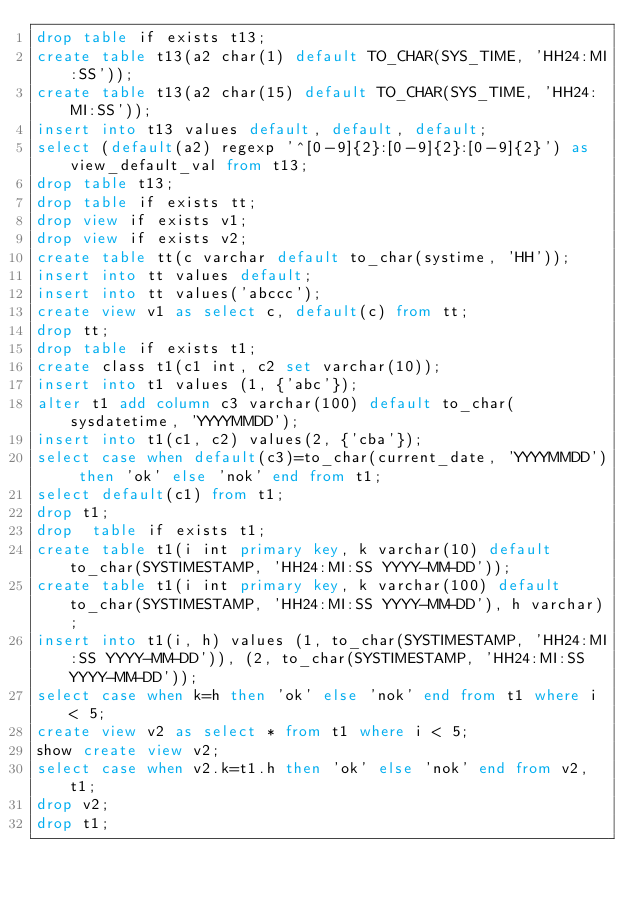<code> <loc_0><loc_0><loc_500><loc_500><_SQL_>drop table if exists t13;
create table t13(a2 char(1) default TO_CHAR(SYS_TIME, 'HH24:MI:SS'));
create table t13(a2 char(15) default TO_CHAR(SYS_TIME, 'HH24:MI:SS'));
insert into t13 values default, default, default;
select (default(a2) regexp '^[0-9]{2}:[0-9]{2}:[0-9]{2}') as view_default_val from t13;
drop table t13;
drop table if exists tt;
drop view if exists v1;
drop view if exists v2;
create table tt(c varchar default to_char(systime, 'HH'));
insert into tt values default;
insert into tt values('abccc');
create view v1 as select c, default(c) from tt;
drop tt;
drop table if exists t1;
create class t1(c1 int, c2 set varchar(10));
insert into t1 values (1, {'abc'});
alter t1 add column c3 varchar(100) default to_char(sysdatetime, 'YYYYMMDD');
insert into t1(c1, c2) values(2, {'cba'});
select case when default(c3)=to_char(current_date, 'YYYYMMDD') then 'ok' else 'nok' end from t1;
select default(c1) from t1; 
drop t1;
drop  table if exists t1;
create table t1(i int primary key, k varchar(10) default to_char(SYSTIMESTAMP, 'HH24:MI:SS YYYY-MM-DD'));
create table t1(i int primary key, k varchar(100) default to_char(SYSTIMESTAMP, 'HH24:MI:SS YYYY-MM-DD'), h varchar);
insert into t1(i, h) values (1, to_char(SYSTIMESTAMP, 'HH24:MI:SS YYYY-MM-DD')), (2, to_char(SYSTIMESTAMP, 'HH24:MI:SS YYYY-MM-DD'));
select case when k=h then 'ok' else 'nok' end from t1 where i < 5;
create view v2 as select * from t1 where i < 5;
show create view v2;
select case when v2.k=t1.h then 'ok' else 'nok' end from v2, t1;
drop v2;
drop t1;
</code> 